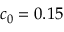Convert formula to latex. <formula><loc_0><loc_0><loc_500><loc_500>c _ { 0 } = 0 . 1 5</formula> 